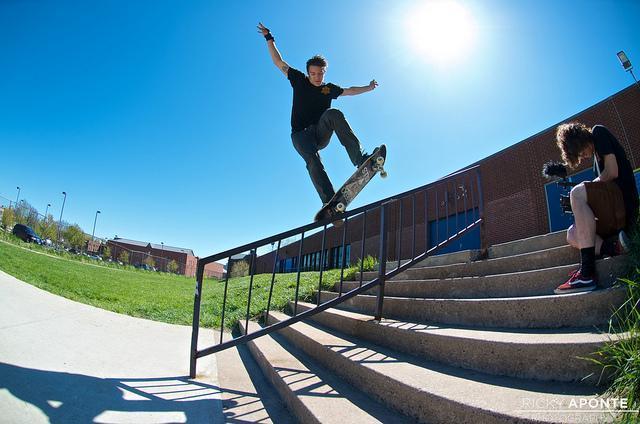How many steps are in this scene?
Give a very brief answer. 7. How many steps are there?
Give a very brief answer. 7. How many people are visible?
Give a very brief answer. 2. How many birds are there?
Give a very brief answer. 0. 